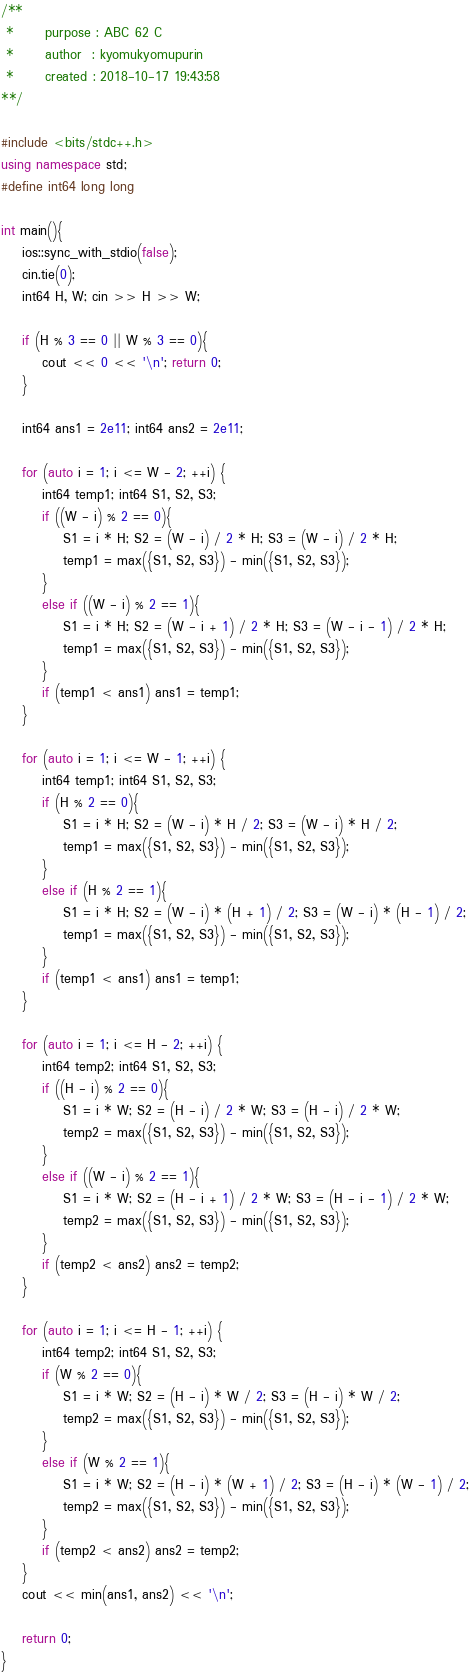<code> <loc_0><loc_0><loc_500><loc_500><_C++_>/**
 *      purpose : ABC 62 C
 *      author  : kyomukyomupurin
 *      created : 2018-10-17 19:43:58
**/

#include <bits/stdc++.h>
using namespace std;
#define int64 long long

int main(){
    ios::sync_with_stdio(false);
    cin.tie(0);
    int64 H, W; cin >> H >> W;

    if (H % 3 == 0 || W % 3 == 0){
        cout << 0 << '\n'; return 0;
    }

    int64 ans1 = 2e11; int64 ans2 = 2e11;

    for (auto i = 1; i <= W - 2; ++i) {
        int64 temp1; int64 S1, S2, S3;
        if ((W - i) % 2 == 0){
            S1 = i * H; S2 = (W - i) / 2 * H; S3 = (W - i) / 2 * H;
            temp1 = max({S1, S2, S3}) - min({S1, S2, S3});
        }
        else if ((W - i) % 2 == 1){
            S1 = i * H; S2 = (W - i + 1) / 2 * H; S3 = (W - i - 1) / 2 * H;
            temp1 = max({S1, S2, S3}) - min({S1, S2, S3});
        }
        if (temp1 < ans1) ans1 = temp1;
    }

    for (auto i = 1; i <= W - 1; ++i) {
        int64 temp1; int64 S1, S2, S3;
        if (H % 2 == 0){
            S1 = i * H; S2 = (W - i) * H / 2; S3 = (W - i) * H / 2;
            temp1 = max({S1, S2, S3}) - min({S1, S2, S3});
        }
        else if (H % 2 == 1){
            S1 = i * H; S2 = (W - i) * (H + 1) / 2; S3 = (W - i) * (H - 1) / 2;
            temp1 = max({S1, S2, S3}) - min({S1, S2, S3});
        }
        if (temp1 < ans1) ans1 = temp1;
    }

    for (auto i = 1; i <= H - 2; ++i) {
        int64 temp2; int64 S1, S2, S3;
        if ((H - i) % 2 == 0){
            S1 = i * W; S2 = (H - i) / 2 * W; S3 = (H - i) / 2 * W;
            temp2 = max({S1, S2, S3}) - min({S1, S2, S3});
        }
        else if ((W - i) % 2 == 1){
            S1 = i * W; S2 = (H - i + 1) / 2 * W; S3 = (H - i - 1) / 2 * W;
            temp2 = max({S1, S2, S3}) - min({S1, S2, S3});
        }
        if (temp2 < ans2) ans2 = temp2;
    }

    for (auto i = 1; i <= H - 1; ++i) {
        int64 temp2; int64 S1, S2, S3;
        if (W % 2 == 0){
            S1 = i * W; S2 = (H - i) * W / 2; S3 = (H - i) * W / 2;
            temp2 = max({S1, S2, S3}) - min({S1, S2, S3});
        }
        else if (W % 2 == 1){
            S1 = i * W; S2 = (H - i) * (W + 1) / 2; S3 = (H - i) * (W - 1) / 2;
            temp2 = max({S1, S2, S3}) - min({S1, S2, S3});
        }
        if (temp2 < ans2) ans2 = temp2;
    }
    cout << min(ans1, ans2) << '\n';
    
    return 0;
}</code> 